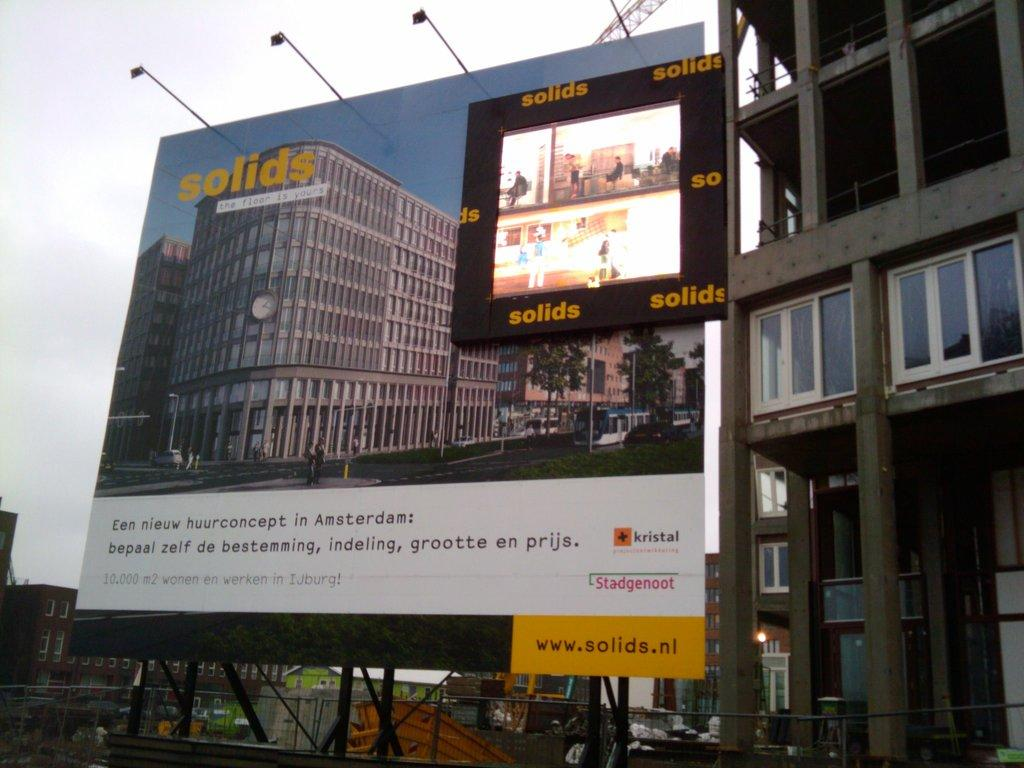<image>
Offer a succinct explanation of the picture presented. lighted billboard for solids and shows their website www.solids.nl 